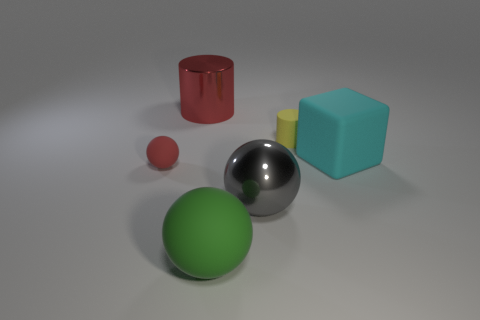Do the big green matte thing and the small yellow matte thing have the same shape?
Your answer should be very brief. No. What is the color of the big thing behind the tiny thing that is behind the cyan thing?
Offer a very short reply. Red. How big is the object that is both to the right of the gray shiny sphere and in front of the small yellow matte cylinder?
Provide a short and direct response. Large. Is there anything else of the same color as the big rubber ball?
Your response must be concise. No. What is the shape of the big green object that is made of the same material as the big cyan block?
Your answer should be very brief. Sphere. Does the cyan thing have the same shape as the metallic object that is in front of the large red shiny thing?
Your response must be concise. No. What is the material of the yellow cylinder that is behind the large green matte ball right of the big metallic cylinder?
Your response must be concise. Rubber. Are there an equal number of large cyan objects that are in front of the small red ball and metal balls?
Offer a terse response. No. Is there anything else that has the same material as the tiny sphere?
Your response must be concise. Yes. Do the rubber thing that is on the right side of the yellow object and the object that is to the left of the large cylinder have the same color?
Ensure brevity in your answer.  No. 